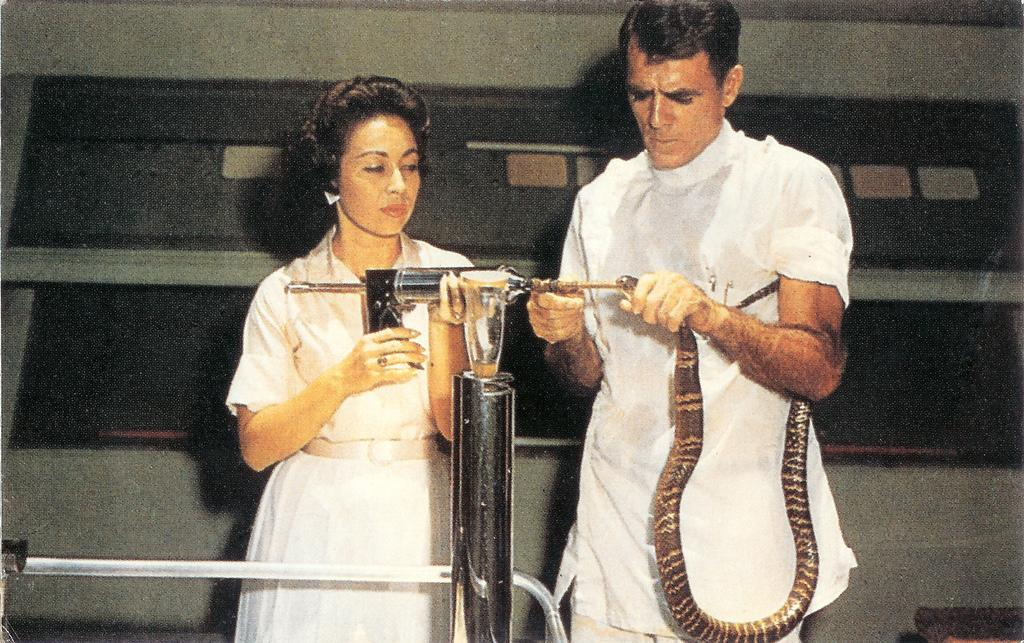How many people are present in the image? There are two persons in the image. What are the people holding in the image? One person is holding a snake, and another person is holding an object. Can you describe any other items in the image? There is a rod in the image. What is visible in the background of the image? There is a wall visible in the background of the image. What type of tree can be seen in the image? There is no tree present in the image. What color is the flag in the image? There is no flag present in the image. 